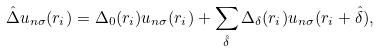Convert formula to latex. <formula><loc_0><loc_0><loc_500><loc_500>\hat { \Delta } u _ { n \sigma } ( r _ { i } ) = \Delta _ { 0 } ( r _ { i } ) u _ { n \sigma } ( r _ { i } ) + \sum _ { \hat { \delta } } \Delta _ { \delta } ( r _ { i } ) u _ { n \sigma } ( r _ { i } + \hat { \delta } ) ,</formula> 